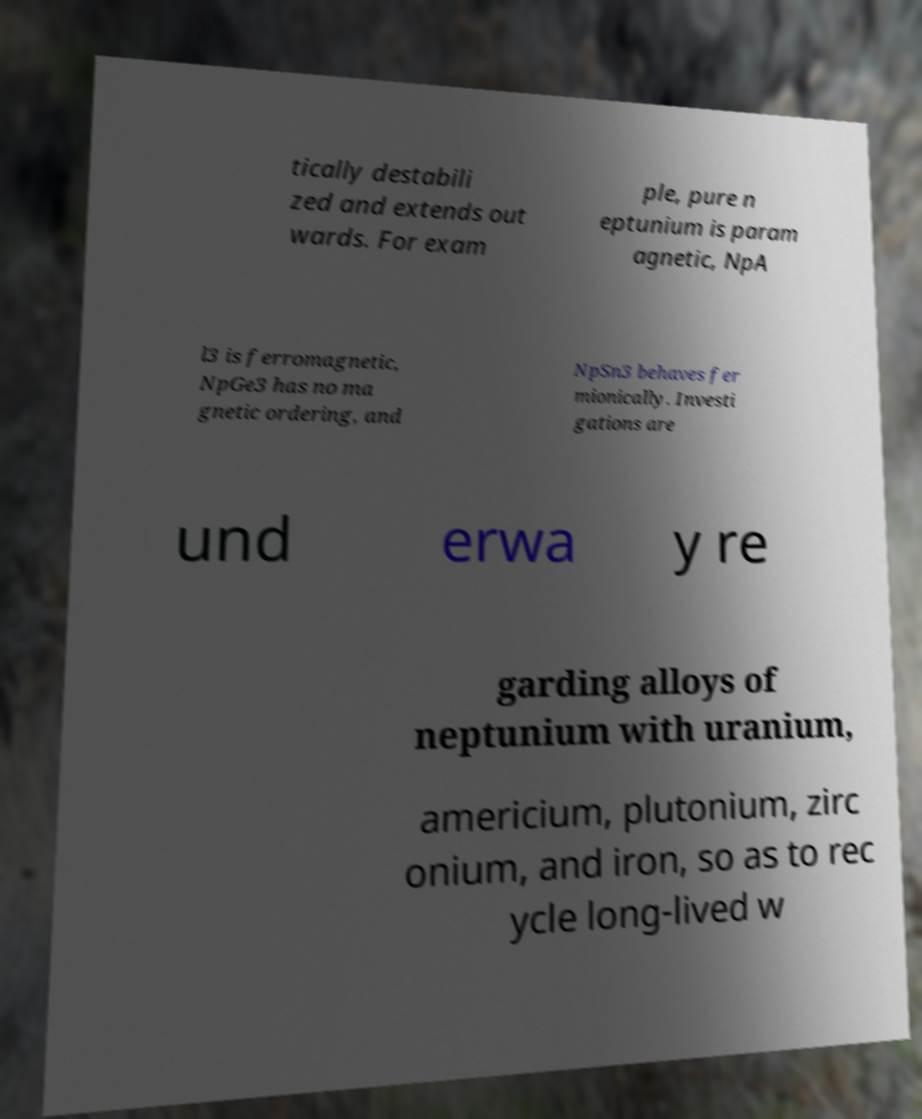There's text embedded in this image that I need extracted. Can you transcribe it verbatim? tically destabili zed and extends out wards. For exam ple, pure n eptunium is param agnetic, NpA l3 is ferromagnetic, NpGe3 has no ma gnetic ordering, and NpSn3 behaves fer mionically. Investi gations are und erwa y re garding alloys of neptunium with uranium, americium, plutonium, zirc onium, and iron, so as to rec ycle long-lived w 